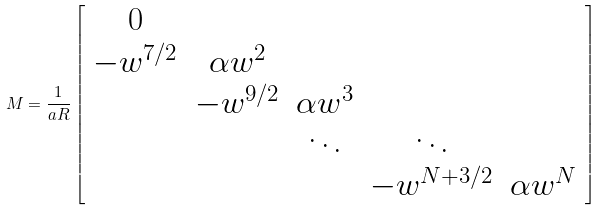Convert formula to latex. <formula><loc_0><loc_0><loc_500><loc_500>M = \frac { 1 } { a R } \left [ \begin{array} { c c c c c } 0 \\ - w ^ { 7 / 2 } & \alpha w ^ { 2 } \\ & - w ^ { 9 / 2 } & \alpha w ^ { 3 } \\ & & \ddots & \ddots \\ & & & - w ^ { N + 3 / 2 } & \alpha w ^ { N } \\ \end{array} \right ]</formula> 